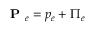Convert formula to latex. <formula><loc_0><loc_0><loc_500><loc_500>P _ { e } = p _ { e } + \Pi _ { e }</formula> 